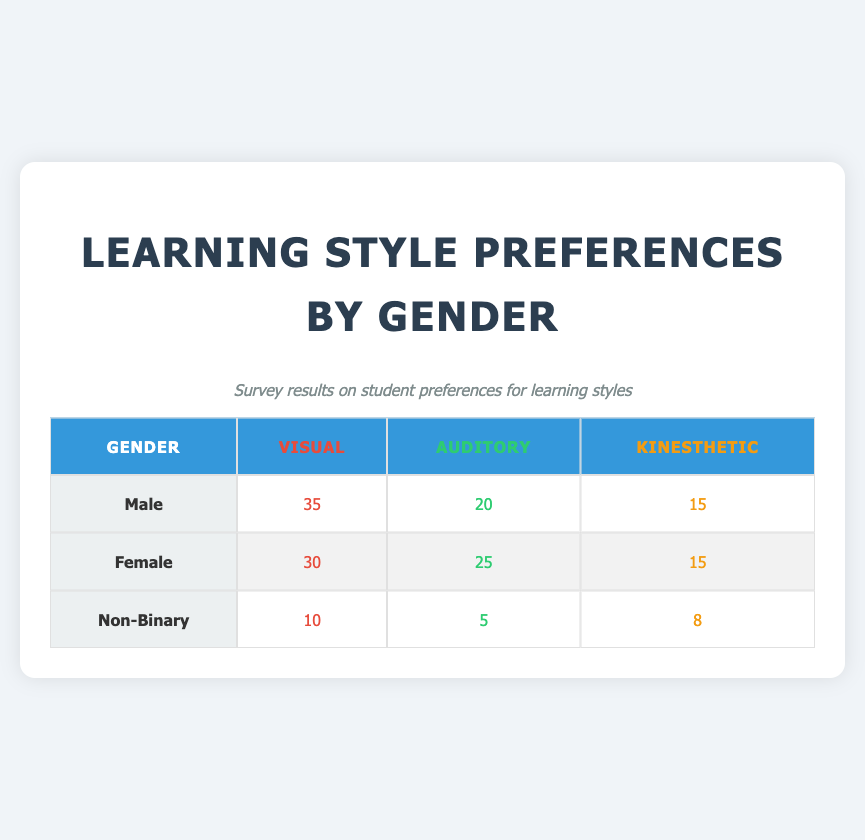What is the count of Male students who prefer Auditory learning? The table lists the preferences of Male students, and under the Auditory column for Male, the value is 20.
Answer: 20 How many Non-Binary students prefer Visual learning? Referring to the Non-Binary row, under the Visual column, there are 10 students who prefer this learning style.
Answer: 10 Which gender has the highest preference for Kinesthetic learning? By reviewing the Kinesthetic column, Male, Female, and Non-Binary have counts of 15, 15, and 8 respectively. Both Male and Female have the same highest count of 15.
Answer: Male and Female What is the total number of respondents who prefer Auditory learning? To find the total, we add the counts from each gender: Male (20) + Female (25) + Non-Binary (5) = 50.
Answer: 50 Is it true that Female students have a higher preference for Visual learning than Male students? The Female count for Visual is 30, while the Male count is 35. Hence, it is false that Female students have a higher preference for Visual learning.
Answer: No What is the difference in preference for Kinesthetic learning between Male and Non-Binary students? The Male count for Kinesthetic learning is 15 and Non-Binary is 8. The difference is calculated as 15 - 8 = 7.
Answer: 7 What percentage of Female students prefer Auditory learning among their gender? There are 25 Female students who prefer Auditory out of a total of 70 Female students (30 Visual + 25 Auditory + 15 Kinesthetic). To find the percentage, we calculate (25 / 70) * 100 = 35.71%.
Answer: 35.71% Which learning style has the lowest preference among Non-Binary students? By examining the Non-Binary row, Auditory (5) has the lowest count compared to Visual (10) and Kinesthetic (8).
Answer: Auditory What is the average preference for Visual learning among all genders? The average for Visual learning is calculated by taking the sum of the preferences for each gender (35 for Male, 30 for Female, and 10 for Non-Binary), which is 35 + 30 + 10 = 75. Dividing by the number of gender categories (3), we get 75 / 3 = 25.
Answer: 25 